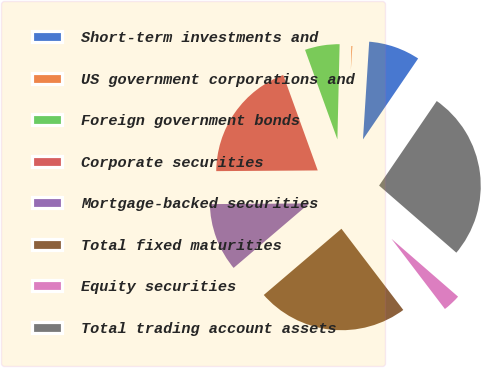Convert chart. <chart><loc_0><loc_0><loc_500><loc_500><pie_chart><fcel>Short-term investments and<fcel>US government corporations and<fcel>Foreign government bonds<fcel>Corporate securities<fcel>Mortgage-backed securities<fcel>Total fixed maturities<fcel>Equity securities<fcel>Total trading account assets<nl><fcel>8.51%<fcel>0.64%<fcel>5.89%<fcel>19.59%<fcel>11.13%<fcel>24.12%<fcel>3.26%<fcel>26.86%<nl></chart> 